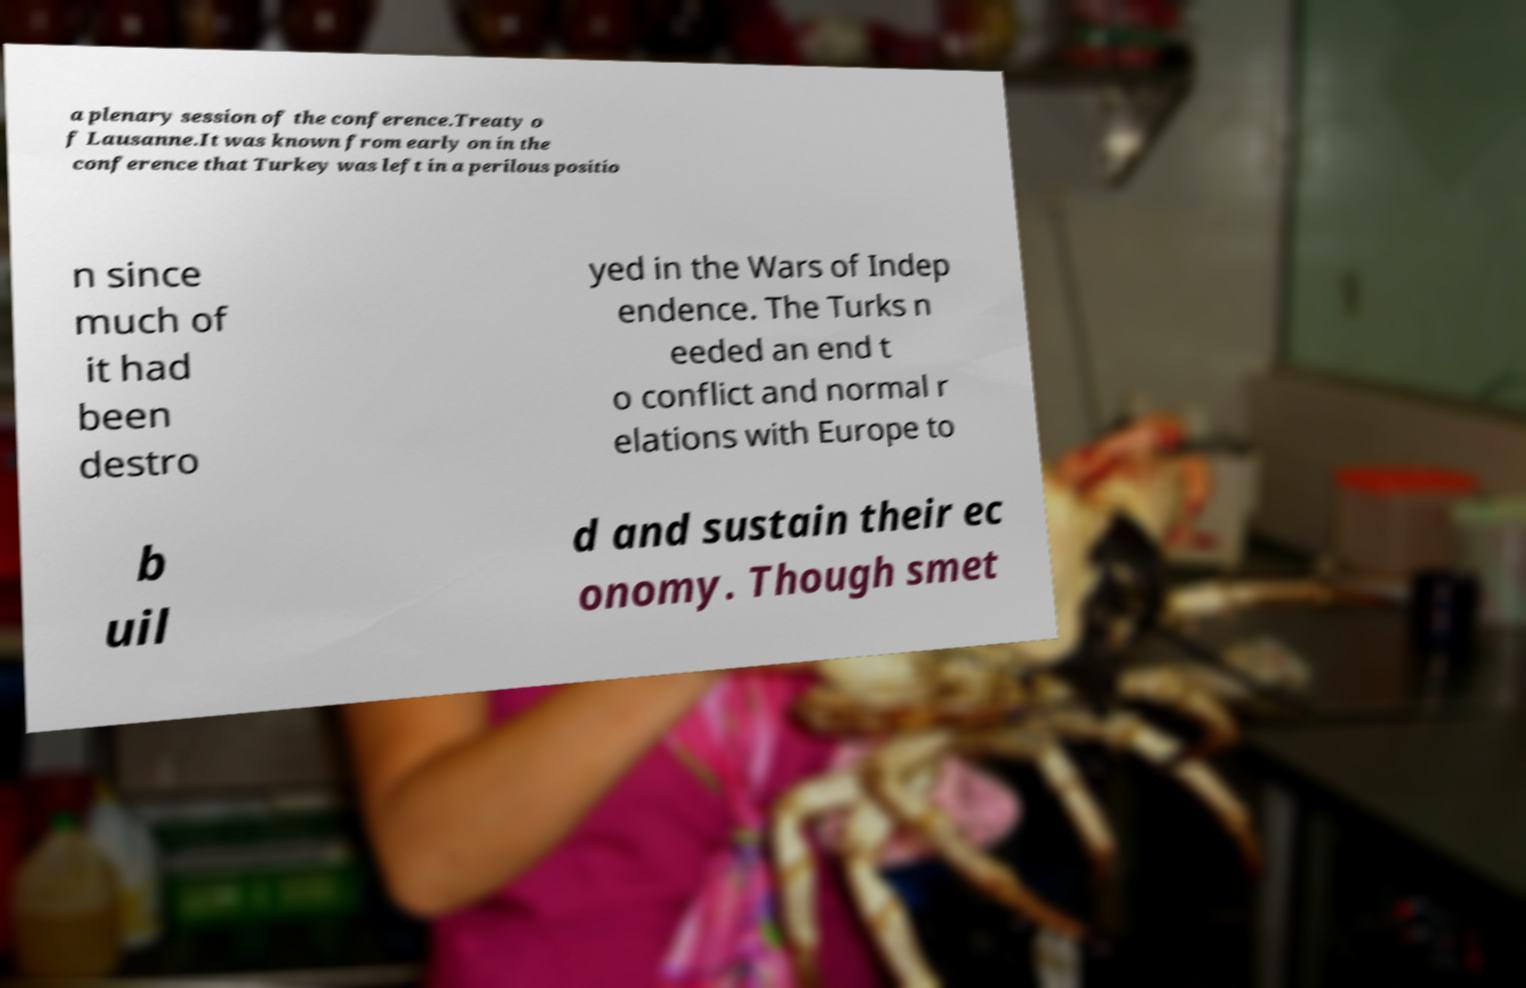What messages or text are displayed in this image? I need them in a readable, typed format. a plenary session of the conference.Treaty o f Lausanne.It was known from early on in the conference that Turkey was left in a perilous positio n since much of it had been destro yed in the Wars of Indep endence. The Turks n eeded an end t o conflict and normal r elations with Europe to b uil d and sustain their ec onomy. Though smet 